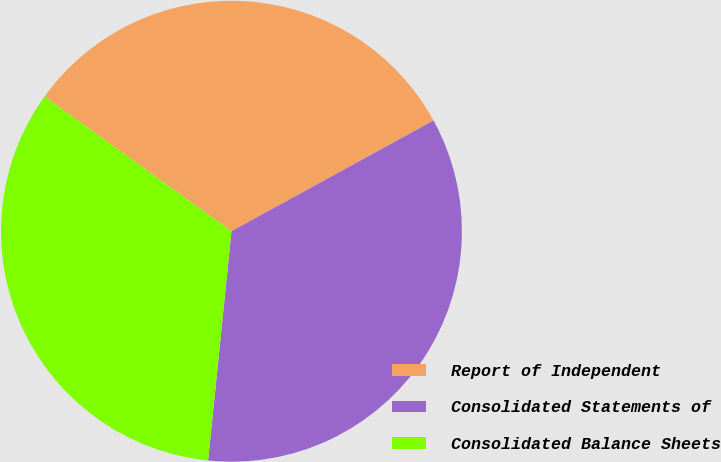<chart> <loc_0><loc_0><loc_500><loc_500><pie_chart><fcel>Report of Independent<fcel>Consolidated Statements of<fcel>Consolidated Balance Sheets<nl><fcel>32.08%<fcel>34.59%<fcel>33.33%<nl></chart> 